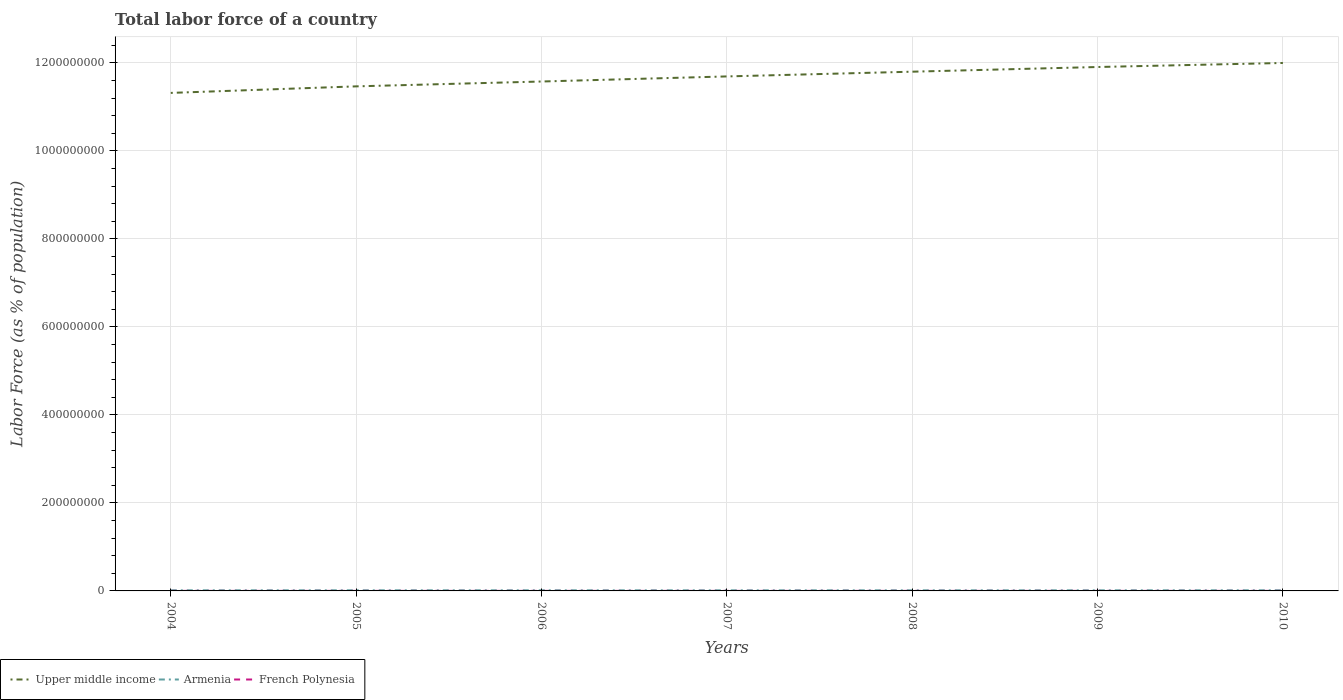How many different coloured lines are there?
Make the answer very short. 3. Does the line corresponding to Upper middle income intersect with the line corresponding to Armenia?
Keep it short and to the point. No. Across all years, what is the maximum percentage of labor force in French Polynesia?
Provide a short and direct response. 1.03e+05. What is the total percentage of labor force in French Polynesia in the graph?
Provide a succinct answer. -3762. What is the difference between the highest and the second highest percentage of labor force in Armenia?
Ensure brevity in your answer.  7.38e+04. What is the difference between the highest and the lowest percentage of labor force in French Polynesia?
Keep it short and to the point. 3. How many lines are there?
Offer a terse response. 3. What is the difference between two consecutive major ticks on the Y-axis?
Your response must be concise. 2.00e+08. Are the values on the major ticks of Y-axis written in scientific E-notation?
Offer a very short reply. No. Does the graph contain grids?
Give a very brief answer. Yes. Where does the legend appear in the graph?
Provide a short and direct response. Bottom left. How many legend labels are there?
Ensure brevity in your answer.  3. What is the title of the graph?
Give a very brief answer. Total labor force of a country. What is the label or title of the X-axis?
Keep it short and to the point. Years. What is the label or title of the Y-axis?
Your answer should be very brief. Labor Force (as % of population). What is the Labor Force (as % of population) in Upper middle income in 2004?
Give a very brief answer. 1.13e+09. What is the Labor Force (as % of population) in Armenia in 2004?
Make the answer very short. 1.44e+06. What is the Labor Force (as % of population) of French Polynesia in 2004?
Your answer should be very brief. 1.03e+05. What is the Labor Force (as % of population) of Upper middle income in 2005?
Your answer should be compact. 1.15e+09. What is the Labor Force (as % of population) in Armenia in 2005?
Make the answer very short. 1.42e+06. What is the Labor Force (as % of population) of French Polynesia in 2005?
Ensure brevity in your answer.  1.04e+05. What is the Labor Force (as % of population) of Upper middle income in 2006?
Provide a succinct answer. 1.16e+09. What is the Labor Force (as % of population) in Armenia in 2006?
Your answer should be compact. 1.40e+06. What is the Labor Force (as % of population) of French Polynesia in 2006?
Make the answer very short. 1.06e+05. What is the Labor Force (as % of population) of Upper middle income in 2007?
Ensure brevity in your answer.  1.17e+09. What is the Labor Force (as % of population) in Armenia in 2007?
Your answer should be very brief. 1.39e+06. What is the Labor Force (as % of population) in French Polynesia in 2007?
Your answer should be very brief. 1.08e+05. What is the Labor Force (as % of population) in Upper middle income in 2008?
Your answer should be compact. 1.18e+09. What is the Labor Force (as % of population) in Armenia in 2008?
Ensure brevity in your answer.  1.38e+06. What is the Labor Force (as % of population) in French Polynesia in 2008?
Your answer should be compact. 1.10e+05. What is the Labor Force (as % of population) in Upper middle income in 2009?
Your answer should be compact. 1.19e+09. What is the Labor Force (as % of population) of Armenia in 2009?
Offer a terse response. 1.39e+06. What is the Labor Force (as % of population) in French Polynesia in 2009?
Provide a short and direct response. 1.12e+05. What is the Labor Force (as % of population) of Upper middle income in 2010?
Provide a short and direct response. 1.20e+09. What is the Labor Force (as % of population) in Armenia in 2010?
Offer a terse response. 1.45e+06. What is the Labor Force (as % of population) of French Polynesia in 2010?
Your answer should be compact. 1.14e+05. Across all years, what is the maximum Labor Force (as % of population) in Upper middle income?
Offer a very short reply. 1.20e+09. Across all years, what is the maximum Labor Force (as % of population) in Armenia?
Provide a short and direct response. 1.45e+06. Across all years, what is the maximum Labor Force (as % of population) of French Polynesia?
Your answer should be compact. 1.14e+05. Across all years, what is the minimum Labor Force (as % of population) in Upper middle income?
Offer a very short reply. 1.13e+09. Across all years, what is the minimum Labor Force (as % of population) of Armenia?
Your response must be concise. 1.38e+06. Across all years, what is the minimum Labor Force (as % of population) in French Polynesia?
Offer a terse response. 1.03e+05. What is the total Labor Force (as % of population) of Upper middle income in the graph?
Your response must be concise. 8.17e+09. What is the total Labor Force (as % of population) in Armenia in the graph?
Offer a very short reply. 9.87e+06. What is the total Labor Force (as % of population) in French Polynesia in the graph?
Offer a very short reply. 7.57e+05. What is the difference between the Labor Force (as % of population) in Upper middle income in 2004 and that in 2005?
Give a very brief answer. -1.49e+07. What is the difference between the Labor Force (as % of population) of Armenia in 2004 and that in 2005?
Keep it short and to the point. 1.49e+04. What is the difference between the Labor Force (as % of population) in French Polynesia in 2004 and that in 2005?
Ensure brevity in your answer.  -1497. What is the difference between the Labor Force (as % of population) of Upper middle income in 2004 and that in 2006?
Ensure brevity in your answer.  -2.59e+07. What is the difference between the Labor Force (as % of population) of Armenia in 2004 and that in 2006?
Give a very brief answer. 3.28e+04. What is the difference between the Labor Force (as % of population) of French Polynesia in 2004 and that in 2006?
Provide a succinct answer. -3199. What is the difference between the Labor Force (as % of population) of Upper middle income in 2004 and that in 2007?
Your answer should be very brief. -3.75e+07. What is the difference between the Labor Force (as % of population) in Armenia in 2004 and that in 2007?
Your answer should be very brief. 4.72e+04. What is the difference between the Labor Force (as % of population) in French Polynesia in 2004 and that in 2007?
Make the answer very short. -4776. What is the difference between the Labor Force (as % of population) in Upper middle income in 2004 and that in 2008?
Provide a succinct answer. -4.82e+07. What is the difference between the Labor Force (as % of population) in Armenia in 2004 and that in 2008?
Your answer should be very brief. 5.98e+04. What is the difference between the Labor Force (as % of population) of French Polynesia in 2004 and that in 2008?
Give a very brief answer. -6961. What is the difference between the Labor Force (as % of population) of Upper middle income in 2004 and that in 2009?
Make the answer very short. -5.88e+07. What is the difference between the Labor Force (as % of population) of Armenia in 2004 and that in 2009?
Offer a very short reply. 4.37e+04. What is the difference between the Labor Force (as % of population) in French Polynesia in 2004 and that in 2009?
Keep it short and to the point. -9045. What is the difference between the Labor Force (as % of population) in Upper middle income in 2004 and that in 2010?
Keep it short and to the point. -6.80e+07. What is the difference between the Labor Force (as % of population) of Armenia in 2004 and that in 2010?
Ensure brevity in your answer.  -1.40e+04. What is the difference between the Labor Force (as % of population) in French Polynesia in 2004 and that in 2010?
Give a very brief answer. -1.09e+04. What is the difference between the Labor Force (as % of population) in Upper middle income in 2005 and that in 2006?
Provide a short and direct response. -1.10e+07. What is the difference between the Labor Force (as % of population) in Armenia in 2005 and that in 2006?
Keep it short and to the point. 1.80e+04. What is the difference between the Labor Force (as % of population) of French Polynesia in 2005 and that in 2006?
Provide a short and direct response. -1702. What is the difference between the Labor Force (as % of population) of Upper middle income in 2005 and that in 2007?
Ensure brevity in your answer.  -2.26e+07. What is the difference between the Labor Force (as % of population) of Armenia in 2005 and that in 2007?
Make the answer very short. 3.24e+04. What is the difference between the Labor Force (as % of population) of French Polynesia in 2005 and that in 2007?
Your answer should be compact. -3279. What is the difference between the Labor Force (as % of population) of Upper middle income in 2005 and that in 2008?
Ensure brevity in your answer.  -3.33e+07. What is the difference between the Labor Force (as % of population) of Armenia in 2005 and that in 2008?
Offer a very short reply. 4.49e+04. What is the difference between the Labor Force (as % of population) in French Polynesia in 2005 and that in 2008?
Keep it short and to the point. -5464. What is the difference between the Labor Force (as % of population) in Upper middle income in 2005 and that in 2009?
Provide a short and direct response. -4.40e+07. What is the difference between the Labor Force (as % of population) of Armenia in 2005 and that in 2009?
Make the answer very short. 2.88e+04. What is the difference between the Labor Force (as % of population) of French Polynesia in 2005 and that in 2009?
Keep it short and to the point. -7548. What is the difference between the Labor Force (as % of population) of Upper middle income in 2005 and that in 2010?
Your answer should be very brief. -5.32e+07. What is the difference between the Labor Force (as % of population) of Armenia in 2005 and that in 2010?
Offer a terse response. -2.88e+04. What is the difference between the Labor Force (as % of population) of French Polynesia in 2005 and that in 2010?
Offer a terse response. -9406. What is the difference between the Labor Force (as % of population) in Upper middle income in 2006 and that in 2007?
Provide a short and direct response. -1.16e+07. What is the difference between the Labor Force (as % of population) of Armenia in 2006 and that in 2007?
Your response must be concise. 1.44e+04. What is the difference between the Labor Force (as % of population) of French Polynesia in 2006 and that in 2007?
Keep it short and to the point. -1577. What is the difference between the Labor Force (as % of population) of Upper middle income in 2006 and that in 2008?
Keep it short and to the point. -2.23e+07. What is the difference between the Labor Force (as % of population) of Armenia in 2006 and that in 2008?
Give a very brief answer. 2.69e+04. What is the difference between the Labor Force (as % of population) in French Polynesia in 2006 and that in 2008?
Ensure brevity in your answer.  -3762. What is the difference between the Labor Force (as % of population) of Upper middle income in 2006 and that in 2009?
Make the answer very short. -3.29e+07. What is the difference between the Labor Force (as % of population) in Armenia in 2006 and that in 2009?
Ensure brevity in your answer.  1.08e+04. What is the difference between the Labor Force (as % of population) of French Polynesia in 2006 and that in 2009?
Make the answer very short. -5846. What is the difference between the Labor Force (as % of population) of Upper middle income in 2006 and that in 2010?
Your response must be concise. -4.21e+07. What is the difference between the Labor Force (as % of population) in Armenia in 2006 and that in 2010?
Offer a very short reply. -4.68e+04. What is the difference between the Labor Force (as % of population) of French Polynesia in 2006 and that in 2010?
Your response must be concise. -7704. What is the difference between the Labor Force (as % of population) in Upper middle income in 2007 and that in 2008?
Offer a very short reply. -1.07e+07. What is the difference between the Labor Force (as % of population) in Armenia in 2007 and that in 2008?
Offer a terse response. 1.25e+04. What is the difference between the Labor Force (as % of population) in French Polynesia in 2007 and that in 2008?
Your answer should be compact. -2185. What is the difference between the Labor Force (as % of population) of Upper middle income in 2007 and that in 2009?
Keep it short and to the point. -2.14e+07. What is the difference between the Labor Force (as % of population) of Armenia in 2007 and that in 2009?
Provide a succinct answer. -3577. What is the difference between the Labor Force (as % of population) in French Polynesia in 2007 and that in 2009?
Offer a very short reply. -4269. What is the difference between the Labor Force (as % of population) of Upper middle income in 2007 and that in 2010?
Keep it short and to the point. -3.06e+07. What is the difference between the Labor Force (as % of population) in Armenia in 2007 and that in 2010?
Your response must be concise. -6.12e+04. What is the difference between the Labor Force (as % of population) in French Polynesia in 2007 and that in 2010?
Make the answer very short. -6127. What is the difference between the Labor Force (as % of population) in Upper middle income in 2008 and that in 2009?
Provide a succinct answer. -1.06e+07. What is the difference between the Labor Force (as % of population) in Armenia in 2008 and that in 2009?
Your response must be concise. -1.61e+04. What is the difference between the Labor Force (as % of population) in French Polynesia in 2008 and that in 2009?
Provide a succinct answer. -2084. What is the difference between the Labor Force (as % of population) in Upper middle income in 2008 and that in 2010?
Keep it short and to the point. -1.98e+07. What is the difference between the Labor Force (as % of population) in Armenia in 2008 and that in 2010?
Ensure brevity in your answer.  -7.38e+04. What is the difference between the Labor Force (as % of population) of French Polynesia in 2008 and that in 2010?
Make the answer very short. -3942. What is the difference between the Labor Force (as % of population) in Upper middle income in 2009 and that in 2010?
Provide a succinct answer. -9.18e+06. What is the difference between the Labor Force (as % of population) of Armenia in 2009 and that in 2010?
Give a very brief answer. -5.77e+04. What is the difference between the Labor Force (as % of population) of French Polynesia in 2009 and that in 2010?
Offer a very short reply. -1858. What is the difference between the Labor Force (as % of population) in Upper middle income in 2004 and the Labor Force (as % of population) in Armenia in 2005?
Offer a terse response. 1.13e+09. What is the difference between the Labor Force (as % of population) of Upper middle income in 2004 and the Labor Force (as % of population) of French Polynesia in 2005?
Offer a terse response. 1.13e+09. What is the difference between the Labor Force (as % of population) of Armenia in 2004 and the Labor Force (as % of population) of French Polynesia in 2005?
Your answer should be very brief. 1.33e+06. What is the difference between the Labor Force (as % of population) of Upper middle income in 2004 and the Labor Force (as % of population) of Armenia in 2006?
Offer a very short reply. 1.13e+09. What is the difference between the Labor Force (as % of population) of Upper middle income in 2004 and the Labor Force (as % of population) of French Polynesia in 2006?
Give a very brief answer. 1.13e+09. What is the difference between the Labor Force (as % of population) in Armenia in 2004 and the Labor Force (as % of population) in French Polynesia in 2006?
Your answer should be very brief. 1.33e+06. What is the difference between the Labor Force (as % of population) in Upper middle income in 2004 and the Labor Force (as % of population) in Armenia in 2007?
Offer a terse response. 1.13e+09. What is the difference between the Labor Force (as % of population) of Upper middle income in 2004 and the Labor Force (as % of population) of French Polynesia in 2007?
Ensure brevity in your answer.  1.13e+09. What is the difference between the Labor Force (as % of population) of Armenia in 2004 and the Labor Force (as % of population) of French Polynesia in 2007?
Your response must be concise. 1.33e+06. What is the difference between the Labor Force (as % of population) of Upper middle income in 2004 and the Labor Force (as % of population) of Armenia in 2008?
Keep it short and to the point. 1.13e+09. What is the difference between the Labor Force (as % of population) in Upper middle income in 2004 and the Labor Force (as % of population) in French Polynesia in 2008?
Give a very brief answer. 1.13e+09. What is the difference between the Labor Force (as % of population) of Armenia in 2004 and the Labor Force (as % of population) of French Polynesia in 2008?
Offer a very short reply. 1.33e+06. What is the difference between the Labor Force (as % of population) of Upper middle income in 2004 and the Labor Force (as % of population) of Armenia in 2009?
Offer a very short reply. 1.13e+09. What is the difference between the Labor Force (as % of population) of Upper middle income in 2004 and the Labor Force (as % of population) of French Polynesia in 2009?
Your answer should be compact. 1.13e+09. What is the difference between the Labor Force (as % of population) in Armenia in 2004 and the Labor Force (as % of population) in French Polynesia in 2009?
Give a very brief answer. 1.33e+06. What is the difference between the Labor Force (as % of population) of Upper middle income in 2004 and the Labor Force (as % of population) of Armenia in 2010?
Offer a terse response. 1.13e+09. What is the difference between the Labor Force (as % of population) in Upper middle income in 2004 and the Labor Force (as % of population) in French Polynesia in 2010?
Your response must be concise. 1.13e+09. What is the difference between the Labor Force (as % of population) in Armenia in 2004 and the Labor Force (as % of population) in French Polynesia in 2010?
Your answer should be compact. 1.32e+06. What is the difference between the Labor Force (as % of population) in Upper middle income in 2005 and the Labor Force (as % of population) in Armenia in 2006?
Give a very brief answer. 1.15e+09. What is the difference between the Labor Force (as % of population) of Upper middle income in 2005 and the Labor Force (as % of population) of French Polynesia in 2006?
Provide a short and direct response. 1.15e+09. What is the difference between the Labor Force (as % of population) of Armenia in 2005 and the Labor Force (as % of population) of French Polynesia in 2006?
Provide a short and direct response. 1.32e+06. What is the difference between the Labor Force (as % of population) in Upper middle income in 2005 and the Labor Force (as % of population) in Armenia in 2007?
Keep it short and to the point. 1.15e+09. What is the difference between the Labor Force (as % of population) in Upper middle income in 2005 and the Labor Force (as % of population) in French Polynesia in 2007?
Provide a succinct answer. 1.15e+09. What is the difference between the Labor Force (as % of population) in Armenia in 2005 and the Labor Force (as % of population) in French Polynesia in 2007?
Your answer should be compact. 1.31e+06. What is the difference between the Labor Force (as % of population) in Upper middle income in 2005 and the Labor Force (as % of population) in Armenia in 2008?
Your response must be concise. 1.15e+09. What is the difference between the Labor Force (as % of population) in Upper middle income in 2005 and the Labor Force (as % of population) in French Polynesia in 2008?
Offer a very short reply. 1.15e+09. What is the difference between the Labor Force (as % of population) in Armenia in 2005 and the Labor Force (as % of population) in French Polynesia in 2008?
Your answer should be compact. 1.31e+06. What is the difference between the Labor Force (as % of population) in Upper middle income in 2005 and the Labor Force (as % of population) in Armenia in 2009?
Keep it short and to the point. 1.15e+09. What is the difference between the Labor Force (as % of population) of Upper middle income in 2005 and the Labor Force (as % of population) of French Polynesia in 2009?
Offer a terse response. 1.15e+09. What is the difference between the Labor Force (as % of population) of Armenia in 2005 and the Labor Force (as % of population) of French Polynesia in 2009?
Provide a succinct answer. 1.31e+06. What is the difference between the Labor Force (as % of population) in Upper middle income in 2005 and the Labor Force (as % of population) in Armenia in 2010?
Make the answer very short. 1.15e+09. What is the difference between the Labor Force (as % of population) of Upper middle income in 2005 and the Labor Force (as % of population) of French Polynesia in 2010?
Your answer should be very brief. 1.15e+09. What is the difference between the Labor Force (as % of population) in Armenia in 2005 and the Labor Force (as % of population) in French Polynesia in 2010?
Give a very brief answer. 1.31e+06. What is the difference between the Labor Force (as % of population) in Upper middle income in 2006 and the Labor Force (as % of population) in Armenia in 2007?
Your answer should be compact. 1.16e+09. What is the difference between the Labor Force (as % of population) of Upper middle income in 2006 and the Labor Force (as % of population) of French Polynesia in 2007?
Offer a very short reply. 1.16e+09. What is the difference between the Labor Force (as % of population) in Armenia in 2006 and the Labor Force (as % of population) in French Polynesia in 2007?
Your answer should be very brief. 1.30e+06. What is the difference between the Labor Force (as % of population) of Upper middle income in 2006 and the Labor Force (as % of population) of Armenia in 2008?
Offer a very short reply. 1.16e+09. What is the difference between the Labor Force (as % of population) of Upper middle income in 2006 and the Labor Force (as % of population) of French Polynesia in 2008?
Provide a short and direct response. 1.16e+09. What is the difference between the Labor Force (as % of population) in Armenia in 2006 and the Labor Force (as % of population) in French Polynesia in 2008?
Your answer should be compact. 1.29e+06. What is the difference between the Labor Force (as % of population) of Upper middle income in 2006 and the Labor Force (as % of population) of Armenia in 2009?
Your answer should be compact. 1.16e+09. What is the difference between the Labor Force (as % of population) of Upper middle income in 2006 and the Labor Force (as % of population) of French Polynesia in 2009?
Make the answer very short. 1.16e+09. What is the difference between the Labor Force (as % of population) in Armenia in 2006 and the Labor Force (as % of population) in French Polynesia in 2009?
Your response must be concise. 1.29e+06. What is the difference between the Labor Force (as % of population) in Upper middle income in 2006 and the Labor Force (as % of population) in Armenia in 2010?
Your answer should be very brief. 1.16e+09. What is the difference between the Labor Force (as % of population) of Upper middle income in 2006 and the Labor Force (as % of population) of French Polynesia in 2010?
Give a very brief answer. 1.16e+09. What is the difference between the Labor Force (as % of population) in Armenia in 2006 and the Labor Force (as % of population) in French Polynesia in 2010?
Provide a succinct answer. 1.29e+06. What is the difference between the Labor Force (as % of population) in Upper middle income in 2007 and the Labor Force (as % of population) in Armenia in 2008?
Your response must be concise. 1.17e+09. What is the difference between the Labor Force (as % of population) of Upper middle income in 2007 and the Labor Force (as % of population) of French Polynesia in 2008?
Your answer should be compact. 1.17e+09. What is the difference between the Labor Force (as % of population) in Armenia in 2007 and the Labor Force (as % of population) in French Polynesia in 2008?
Provide a succinct answer. 1.28e+06. What is the difference between the Labor Force (as % of population) in Upper middle income in 2007 and the Labor Force (as % of population) in Armenia in 2009?
Provide a short and direct response. 1.17e+09. What is the difference between the Labor Force (as % of population) of Upper middle income in 2007 and the Labor Force (as % of population) of French Polynesia in 2009?
Give a very brief answer. 1.17e+09. What is the difference between the Labor Force (as % of population) in Armenia in 2007 and the Labor Force (as % of population) in French Polynesia in 2009?
Make the answer very short. 1.28e+06. What is the difference between the Labor Force (as % of population) in Upper middle income in 2007 and the Labor Force (as % of population) in Armenia in 2010?
Make the answer very short. 1.17e+09. What is the difference between the Labor Force (as % of population) in Upper middle income in 2007 and the Labor Force (as % of population) in French Polynesia in 2010?
Offer a very short reply. 1.17e+09. What is the difference between the Labor Force (as % of population) of Armenia in 2007 and the Labor Force (as % of population) of French Polynesia in 2010?
Your answer should be very brief. 1.28e+06. What is the difference between the Labor Force (as % of population) of Upper middle income in 2008 and the Labor Force (as % of population) of Armenia in 2009?
Provide a succinct answer. 1.18e+09. What is the difference between the Labor Force (as % of population) of Upper middle income in 2008 and the Labor Force (as % of population) of French Polynesia in 2009?
Offer a terse response. 1.18e+09. What is the difference between the Labor Force (as % of population) of Armenia in 2008 and the Labor Force (as % of population) of French Polynesia in 2009?
Your answer should be compact. 1.27e+06. What is the difference between the Labor Force (as % of population) of Upper middle income in 2008 and the Labor Force (as % of population) of Armenia in 2010?
Offer a very short reply. 1.18e+09. What is the difference between the Labor Force (as % of population) in Upper middle income in 2008 and the Labor Force (as % of population) in French Polynesia in 2010?
Make the answer very short. 1.18e+09. What is the difference between the Labor Force (as % of population) in Armenia in 2008 and the Labor Force (as % of population) in French Polynesia in 2010?
Your response must be concise. 1.26e+06. What is the difference between the Labor Force (as % of population) in Upper middle income in 2009 and the Labor Force (as % of population) in Armenia in 2010?
Offer a terse response. 1.19e+09. What is the difference between the Labor Force (as % of population) of Upper middle income in 2009 and the Labor Force (as % of population) of French Polynesia in 2010?
Make the answer very short. 1.19e+09. What is the difference between the Labor Force (as % of population) in Armenia in 2009 and the Labor Force (as % of population) in French Polynesia in 2010?
Provide a succinct answer. 1.28e+06. What is the average Labor Force (as % of population) of Upper middle income per year?
Provide a short and direct response. 1.17e+09. What is the average Labor Force (as % of population) in Armenia per year?
Provide a succinct answer. 1.41e+06. What is the average Labor Force (as % of population) in French Polynesia per year?
Make the answer very short. 1.08e+05. In the year 2004, what is the difference between the Labor Force (as % of population) of Upper middle income and Labor Force (as % of population) of Armenia?
Ensure brevity in your answer.  1.13e+09. In the year 2004, what is the difference between the Labor Force (as % of population) of Upper middle income and Labor Force (as % of population) of French Polynesia?
Offer a very short reply. 1.13e+09. In the year 2004, what is the difference between the Labor Force (as % of population) of Armenia and Labor Force (as % of population) of French Polynesia?
Keep it short and to the point. 1.33e+06. In the year 2005, what is the difference between the Labor Force (as % of population) of Upper middle income and Labor Force (as % of population) of Armenia?
Offer a very short reply. 1.15e+09. In the year 2005, what is the difference between the Labor Force (as % of population) of Upper middle income and Labor Force (as % of population) of French Polynesia?
Your answer should be very brief. 1.15e+09. In the year 2005, what is the difference between the Labor Force (as % of population) in Armenia and Labor Force (as % of population) in French Polynesia?
Ensure brevity in your answer.  1.32e+06. In the year 2006, what is the difference between the Labor Force (as % of population) in Upper middle income and Labor Force (as % of population) in Armenia?
Keep it short and to the point. 1.16e+09. In the year 2006, what is the difference between the Labor Force (as % of population) in Upper middle income and Labor Force (as % of population) in French Polynesia?
Provide a succinct answer. 1.16e+09. In the year 2006, what is the difference between the Labor Force (as % of population) in Armenia and Labor Force (as % of population) in French Polynesia?
Your response must be concise. 1.30e+06. In the year 2007, what is the difference between the Labor Force (as % of population) in Upper middle income and Labor Force (as % of population) in Armenia?
Keep it short and to the point. 1.17e+09. In the year 2007, what is the difference between the Labor Force (as % of population) of Upper middle income and Labor Force (as % of population) of French Polynesia?
Provide a succinct answer. 1.17e+09. In the year 2007, what is the difference between the Labor Force (as % of population) of Armenia and Labor Force (as % of population) of French Polynesia?
Your answer should be compact. 1.28e+06. In the year 2008, what is the difference between the Labor Force (as % of population) of Upper middle income and Labor Force (as % of population) of Armenia?
Keep it short and to the point. 1.18e+09. In the year 2008, what is the difference between the Labor Force (as % of population) in Upper middle income and Labor Force (as % of population) in French Polynesia?
Ensure brevity in your answer.  1.18e+09. In the year 2008, what is the difference between the Labor Force (as % of population) of Armenia and Labor Force (as % of population) of French Polynesia?
Provide a short and direct response. 1.27e+06. In the year 2009, what is the difference between the Labor Force (as % of population) of Upper middle income and Labor Force (as % of population) of Armenia?
Your response must be concise. 1.19e+09. In the year 2009, what is the difference between the Labor Force (as % of population) of Upper middle income and Labor Force (as % of population) of French Polynesia?
Keep it short and to the point. 1.19e+09. In the year 2009, what is the difference between the Labor Force (as % of population) of Armenia and Labor Force (as % of population) of French Polynesia?
Keep it short and to the point. 1.28e+06. In the year 2010, what is the difference between the Labor Force (as % of population) in Upper middle income and Labor Force (as % of population) in Armenia?
Offer a very short reply. 1.20e+09. In the year 2010, what is the difference between the Labor Force (as % of population) of Upper middle income and Labor Force (as % of population) of French Polynesia?
Provide a succinct answer. 1.20e+09. In the year 2010, what is the difference between the Labor Force (as % of population) of Armenia and Labor Force (as % of population) of French Polynesia?
Make the answer very short. 1.34e+06. What is the ratio of the Labor Force (as % of population) in Upper middle income in 2004 to that in 2005?
Offer a terse response. 0.99. What is the ratio of the Labor Force (as % of population) of Armenia in 2004 to that in 2005?
Your answer should be very brief. 1.01. What is the ratio of the Labor Force (as % of population) of French Polynesia in 2004 to that in 2005?
Your answer should be very brief. 0.99. What is the ratio of the Labor Force (as % of population) in Upper middle income in 2004 to that in 2006?
Your response must be concise. 0.98. What is the ratio of the Labor Force (as % of population) in Armenia in 2004 to that in 2006?
Provide a succinct answer. 1.02. What is the ratio of the Labor Force (as % of population) of French Polynesia in 2004 to that in 2006?
Your answer should be very brief. 0.97. What is the ratio of the Labor Force (as % of population) of Armenia in 2004 to that in 2007?
Offer a terse response. 1.03. What is the ratio of the Labor Force (as % of population) of French Polynesia in 2004 to that in 2007?
Ensure brevity in your answer.  0.96. What is the ratio of the Labor Force (as % of population) in Upper middle income in 2004 to that in 2008?
Offer a very short reply. 0.96. What is the ratio of the Labor Force (as % of population) of Armenia in 2004 to that in 2008?
Offer a terse response. 1.04. What is the ratio of the Labor Force (as % of population) of French Polynesia in 2004 to that in 2008?
Your answer should be compact. 0.94. What is the ratio of the Labor Force (as % of population) in Upper middle income in 2004 to that in 2009?
Offer a terse response. 0.95. What is the ratio of the Labor Force (as % of population) of Armenia in 2004 to that in 2009?
Make the answer very short. 1.03. What is the ratio of the Labor Force (as % of population) in French Polynesia in 2004 to that in 2009?
Ensure brevity in your answer.  0.92. What is the ratio of the Labor Force (as % of population) in Upper middle income in 2004 to that in 2010?
Provide a succinct answer. 0.94. What is the ratio of the Labor Force (as % of population) in Armenia in 2004 to that in 2010?
Provide a succinct answer. 0.99. What is the ratio of the Labor Force (as % of population) in French Polynesia in 2004 to that in 2010?
Offer a very short reply. 0.9. What is the ratio of the Labor Force (as % of population) of Upper middle income in 2005 to that in 2006?
Keep it short and to the point. 0.99. What is the ratio of the Labor Force (as % of population) of Armenia in 2005 to that in 2006?
Ensure brevity in your answer.  1.01. What is the ratio of the Labor Force (as % of population) of Upper middle income in 2005 to that in 2007?
Provide a succinct answer. 0.98. What is the ratio of the Labor Force (as % of population) in Armenia in 2005 to that in 2007?
Ensure brevity in your answer.  1.02. What is the ratio of the Labor Force (as % of population) in French Polynesia in 2005 to that in 2007?
Offer a very short reply. 0.97. What is the ratio of the Labor Force (as % of population) of Upper middle income in 2005 to that in 2008?
Keep it short and to the point. 0.97. What is the ratio of the Labor Force (as % of population) of Armenia in 2005 to that in 2008?
Give a very brief answer. 1.03. What is the ratio of the Labor Force (as % of population) in French Polynesia in 2005 to that in 2008?
Your answer should be compact. 0.95. What is the ratio of the Labor Force (as % of population) of Upper middle income in 2005 to that in 2009?
Offer a very short reply. 0.96. What is the ratio of the Labor Force (as % of population) of Armenia in 2005 to that in 2009?
Provide a short and direct response. 1.02. What is the ratio of the Labor Force (as % of population) in French Polynesia in 2005 to that in 2009?
Provide a succinct answer. 0.93. What is the ratio of the Labor Force (as % of population) of Upper middle income in 2005 to that in 2010?
Offer a terse response. 0.96. What is the ratio of the Labor Force (as % of population) of Armenia in 2005 to that in 2010?
Your answer should be very brief. 0.98. What is the ratio of the Labor Force (as % of population) in French Polynesia in 2005 to that in 2010?
Offer a very short reply. 0.92. What is the ratio of the Labor Force (as % of population) in Armenia in 2006 to that in 2007?
Ensure brevity in your answer.  1.01. What is the ratio of the Labor Force (as % of population) of French Polynesia in 2006 to that in 2007?
Offer a very short reply. 0.99. What is the ratio of the Labor Force (as % of population) of Upper middle income in 2006 to that in 2008?
Provide a short and direct response. 0.98. What is the ratio of the Labor Force (as % of population) in Armenia in 2006 to that in 2008?
Give a very brief answer. 1.02. What is the ratio of the Labor Force (as % of population) of French Polynesia in 2006 to that in 2008?
Keep it short and to the point. 0.97. What is the ratio of the Labor Force (as % of population) in Upper middle income in 2006 to that in 2009?
Give a very brief answer. 0.97. What is the ratio of the Labor Force (as % of population) of French Polynesia in 2006 to that in 2009?
Your response must be concise. 0.95. What is the ratio of the Labor Force (as % of population) of Upper middle income in 2006 to that in 2010?
Provide a succinct answer. 0.96. What is the ratio of the Labor Force (as % of population) of French Polynesia in 2006 to that in 2010?
Offer a very short reply. 0.93. What is the ratio of the Labor Force (as % of population) of Upper middle income in 2007 to that in 2008?
Offer a terse response. 0.99. What is the ratio of the Labor Force (as % of population) of Armenia in 2007 to that in 2008?
Make the answer very short. 1.01. What is the ratio of the Labor Force (as % of population) of French Polynesia in 2007 to that in 2008?
Make the answer very short. 0.98. What is the ratio of the Labor Force (as % of population) of French Polynesia in 2007 to that in 2009?
Your response must be concise. 0.96. What is the ratio of the Labor Force (as % of population) of Upper middle income in 2007 to that in 2010?
Ensure brevity in your answer.  0.97. What is the ratio of the Labor Force (as % of population) in Armenia in 2007 to that in 2010?
Ensure brevity in your answer.  0.96. What is the ratio of the Labor Force (as % of population) of French Polynesia in 2007 to that in 2010?
Provide a succinct answer. 0.95. What is the ratio of the Labor Force (as % of population) in Upper middle income in 2008 to that in 2009?
Provide a succinct answer. 0.99. What is the ratio of the Labor Force (as % of population) in Armenia in 2008 to that in 2009?
Give a very brief answer. 0.99. What is the ratio of the Labor Force (as % of population) of French Polynesia in 2008 to that in 2009?
Provide a succinct answer. 0.98. What is the ratio of the Labor Force (as % of population) of Upper middle income in 2008 to that in 2010?
Give a very brief answer. 0.98. What is the ratio of the Labor Force (as % of population) in Armenia in 2008 to that in 2010?
Offer a very short reply. 0.95. What is the ratio of the Labor Force (as % of population) of French Polynesia in 2008 to that in 2010?
Keep it short and to the point. 0.97. What is the ratio of the Labor Force (as % of population) in Upper middle income in 2009 to that in 2010?
Offer a terse response. 0.99. What is the ratio of the Labor Force (as % of population) in Armenia in 2009 to that in 2010?
Your answer should be compact. 0.96. What is the ratio of the Labor Force (as % of population) in French Polynesia in 2009 to that in 2010?
Provide a short and direct response. 0.98. What is the difference between the highest and the second highest Labor Force (as % of population) in Upper middle income?
Provide a succinct answer. 9.18e+06. What is the difference between the highest and the second highest Labor Force (as % of population) of Armenia?
Your response must be concise. 1.40e+04. What is the difference between the highest and the second highest Labor Force (as % of population) in French Polynesia?
Make the answer very short. 1858. What is the difference between the highest and the lowest Labor Force (as % of population) of Upper middle income?
Keep it short and to the point. 6.80e+07. What is the difference between the highest and the lowest Labor Force (as % of population) in Armenia?
Keep it short and to the point. 7.38e+04. What is the difference between the highest and the lowest Labor Force (as % of population) of French Polynesia?
Your answer should be very brief. 1.09e+04. 